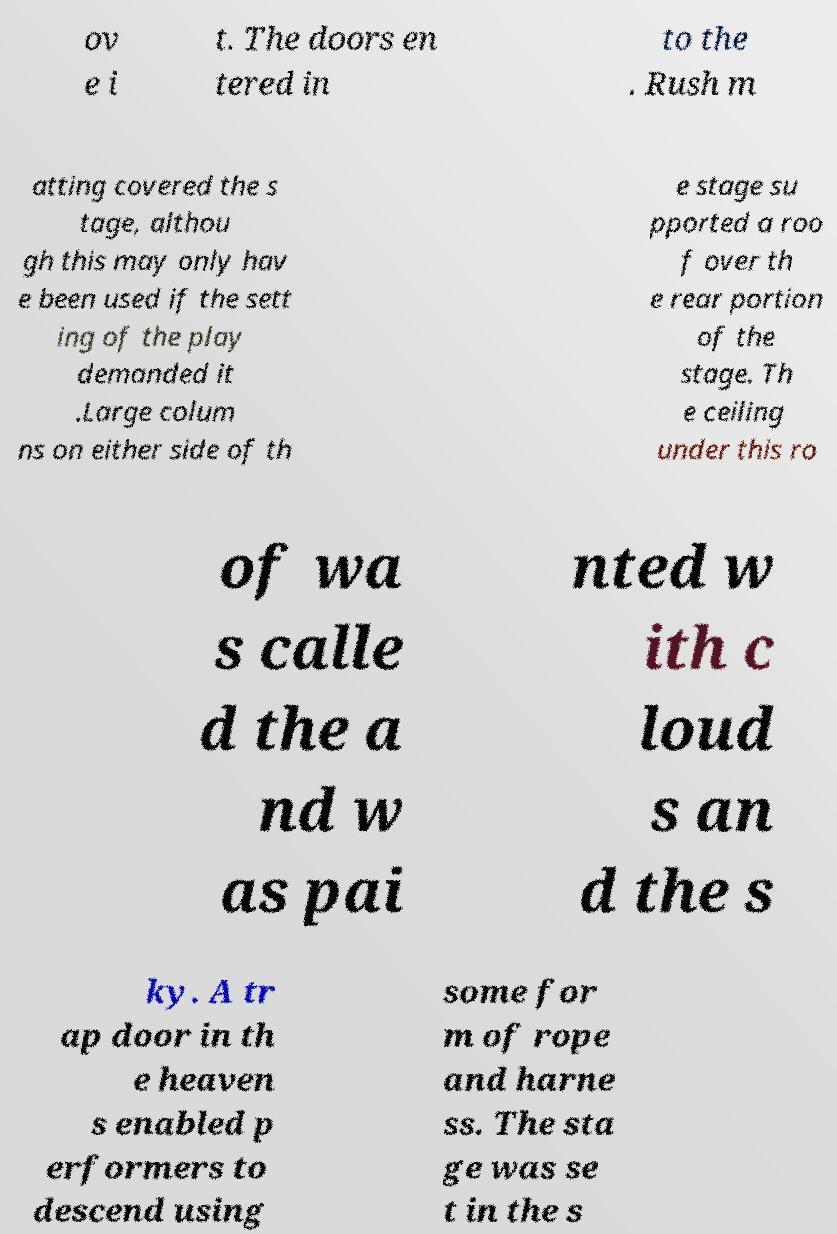Can you accurately transcribe the text from the provided image for me? ov e i t. The doors en tered in to the . Rush m atting covered the s tage, althou gh this may only hav e been used if the sett ing of the play demanded it .Large colum ns on either side of th e stage su pported a roo f over th e rear portion of the stage. Th e ceiling under this ro of wa s calle d the a nd w as pai nted w ith c loud s an d the s ky. A tr ap door in th e heaven s enabled p erformers to descend using some for m of rope and harne ss. The sta ge was se t in the s 